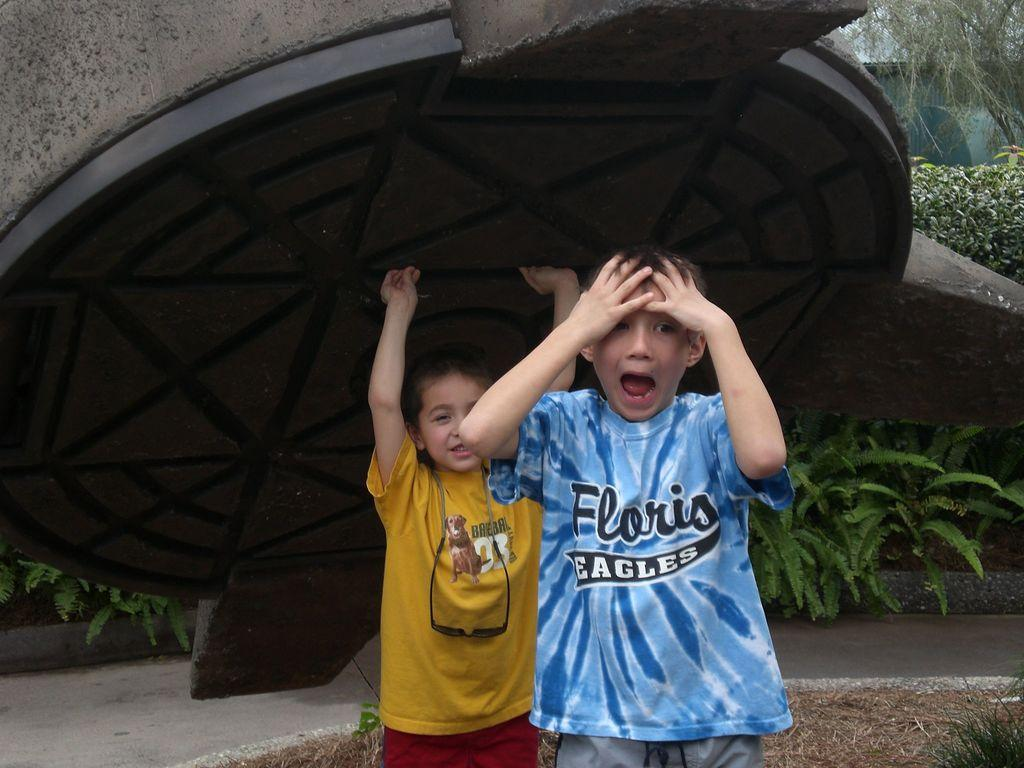How many children are in the image? There are two children in the image. What are the children doing in the image? The children are standing on the ground. What can be seen in the background of the image? There are trees and plants in the background of the image. What type of cracker is the kitty eating on the boat in the image? There is no kitty or boat present in the image; it features two children standing on the ground with trees and plants in the background. 